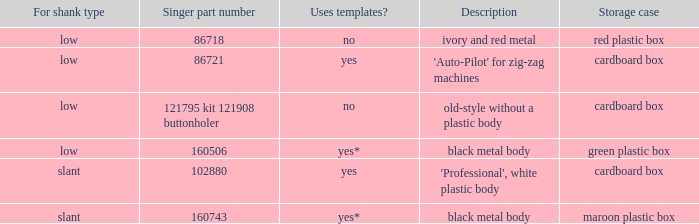What's the storage case of the buttonholer described as ivory and red metal? Red plastic box. 